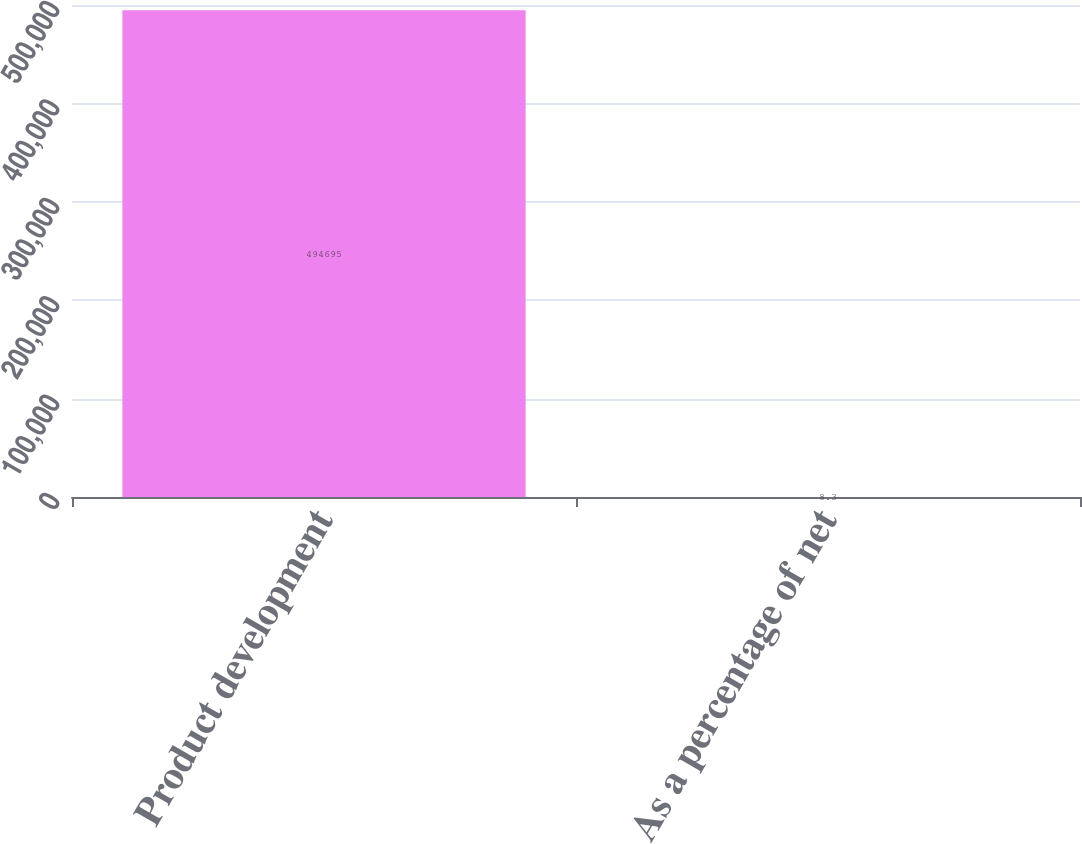<chart> <loc_0><loc_0><loc_500><loc_500><bar_chart><fcel>Product development<fcel>As a percentage of net<nl><fcel>494695<fcel>8.3<nl></chart> 